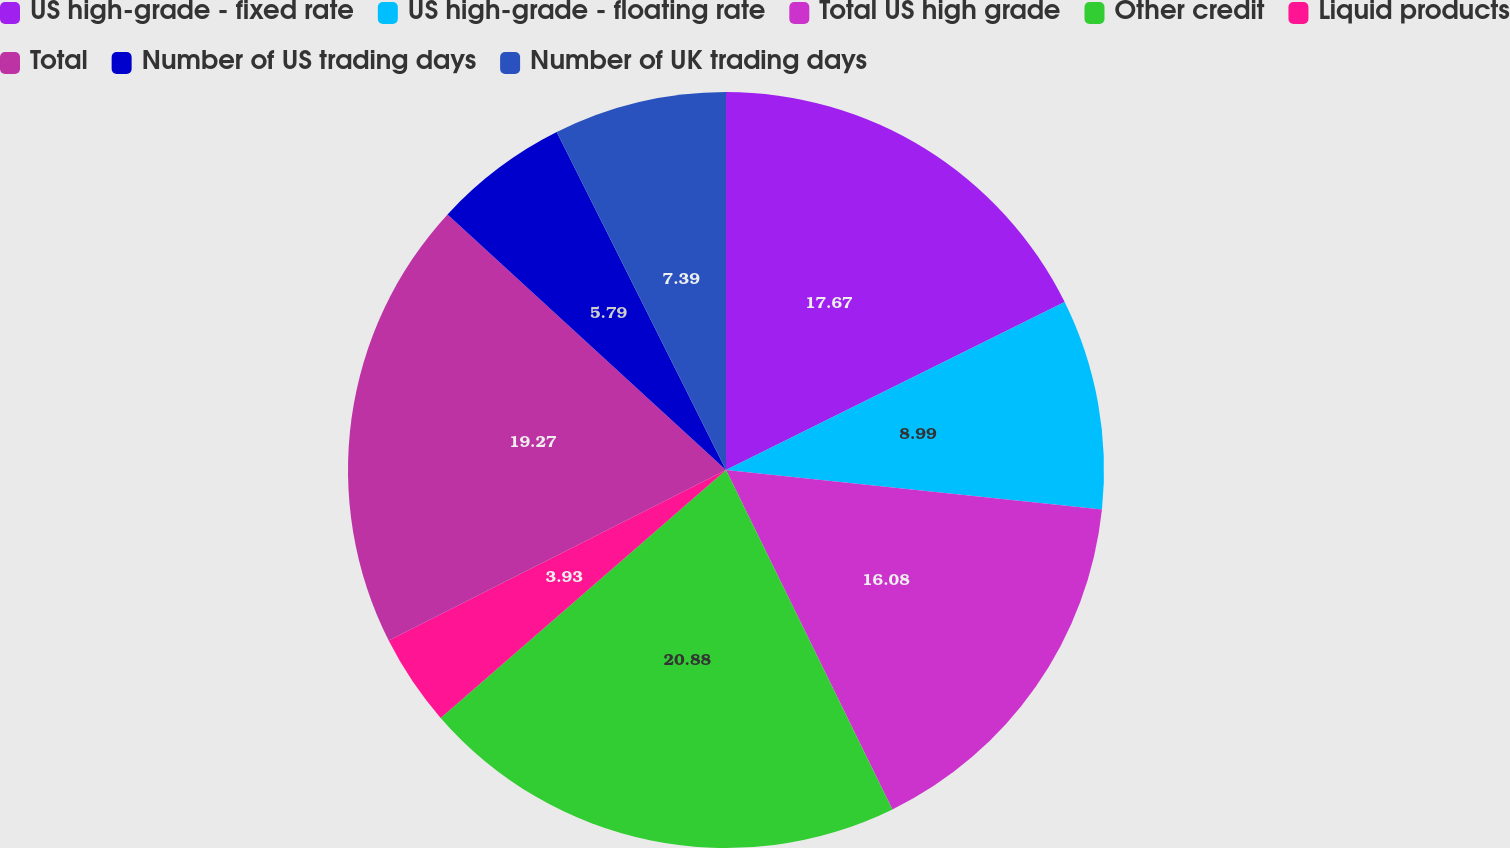Convert chart. <chart><loc_0><loc_0><loc_500><loc_500><pie_chart><fcel>US high-grade - fixed rate<fcel>US high-grade - floating rate<fcel>Total US high grade<fcel>Other credit<fcel>Liquid products<fcel>Total<fcel>Number of US trading days<fcel>Number of UK trading days<nl><fcel>17.67%<fcel>8.99%<fcel>16.08%<fcel>20.87%<fcel>3.93%<fcel>19.27%<fcel>5.79%<fcel>7.39%<nl></chart> 